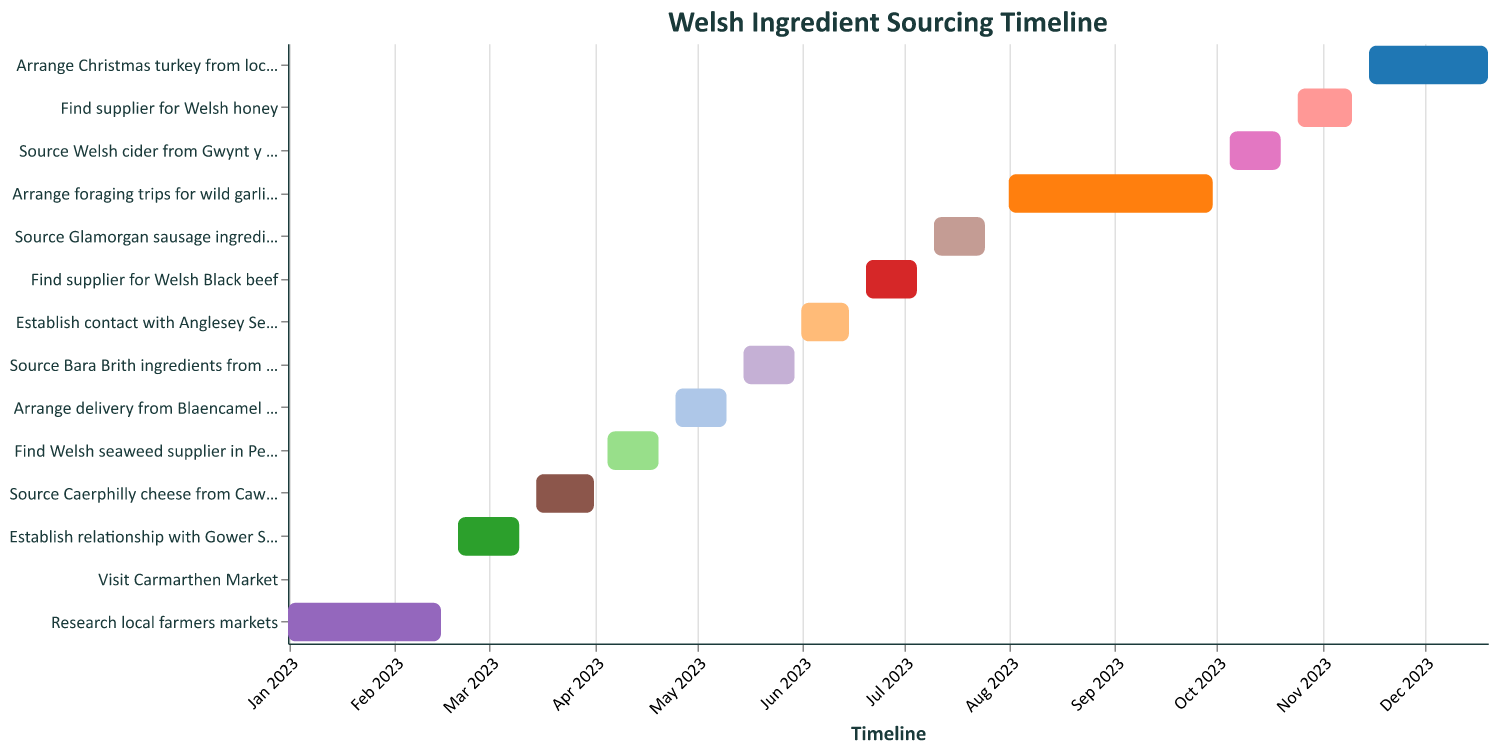What is the title of the Gantt Chart? The title usually appears at the top of the chart, making it easy to identify.
Answer: Welsh Ingredient Sourcing Timeline When does the task "Research local farmers markets" start and end? Look at the bar labeled "Research local farmers markets" and check the start and end dates.
Answer: January 1, 2023 to February 15, 2023 Which two tasks have start dates in June? Identify the task bars starting in June and note their names.
Answer: Establish contact with Anglesey Sea Salt company and Find supplier for Welsh Black beef How long is the gap between the end date of "Source Caerphilly cheese from Caws Cenarth" and the start date of "Find Welsh seaweed supplier in Pembrokeshire"? Observe the end date of "Source Caerphilly cheese from Caws Cenarth" (April 1, 2023) and the start date of "Find Welsh seaweed supplier in Pembrokeshire" (April 5, 2023), then calculate the difference.
Answer: 4 days Which task has the shortest duration? Identify the task bar with the shortest length on the horizontal axis and check its details.
Answer: Visit Carmarthen Market What is the total duration for "Arrange foraging trips for wild garlic and mushrooms"? Check the start and end dates of the task. Calculate the difference in days.
Answer: 61 days What task starts immediately after "Visit Carmarthen Market"? Check the tasks following "Visit Carmarthen Market" and identify the one starting next.
Answer: Establish relationship with Gower Salt Marsh Lamb supplier What is the duration difference between "Arrange delivery from Blaencamel Farm for organic vegetables" and "Source Bara Brith ingredients from local bakery"? Calculate the duration of each task and find the difference.
Answer: 1 day How many tasks start in the month of October? Count the number of bars that begin in October.
Answer: 2 tasks From the tasks listed, which task extends up till the end of the year? Look at the tasks and identify the one that extends to the last date of the year.
Answer: Arrange Christmas turkey from local farm 